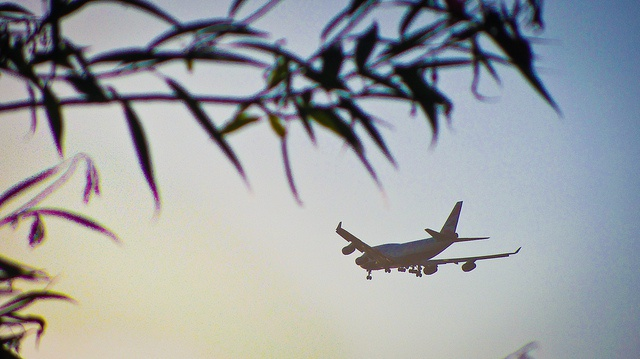Describe the objects in this image and their specific colors. I can see a airplane in darkgray, gray, lightgray, and maroon tones in this image. 